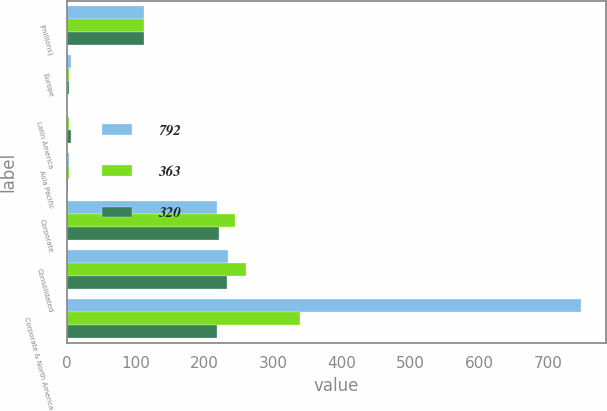Convert chart. <chart><loc_0><loc_0><loc_500><loc_500><stacked_bar_chart><ecel><fcel>(millions)<fcel>Europe<fcel>Latin America<fcel>Asia Pacific<fcel>Corporate<fcel>Consolidated<fcel>Corporate & North America<nl><fcel>792<fcel>112.5<fcel>6<fcel>1<fcel>3<fcel>219<fcel>235<fcel>747<nl><fcel>363<fcel>112.5<fcel>4<fcel>4<fcel>4<fcel>245<fcel>261<fcel>339<nl><fcel>320<fcel>112.5<fcel>4<fcel>6<fcel>2<fcel>221<fcel>233<fcel>219<nl></chart> 